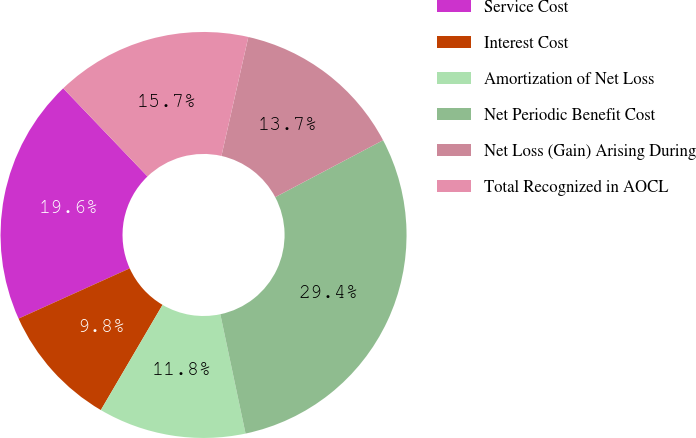Convert chart. <chart><loc_0><loc_0><loc_500><loc_500><pie_chart><fcel>Service Cost<fcel>Interest Cost<fcel>Amortization of Net Loss<fcel>Net Periodic Benefit Cost<fcel>Net Loss (Gain) Arising During<fcel>Total Recognized in AOCL<nl><fcel>19.61%<fcel>9.8%<fcel>11.76%<fcel>29.41%<fcel>13.73%<fcel>15.69%<nl></chart> 